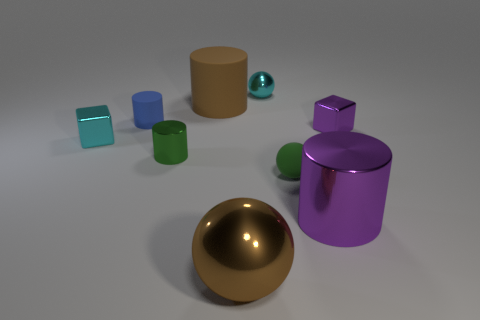Subtract all yellow cylinders. Subtract all green spheres. How many cylinders are left? 4 Subtract all cylinders. How many objects are left? 5 Add 9 green balls. How many green balls exist? 10 Subtract 0 yellow spheres. How many objects are left? 9 Subtract all tiny metallic balls. Subtract all small blue matte things. How many objects are left? 7 Add 6 big purple metallic cylinders. How many big purple metallic cylinders are left? 7 